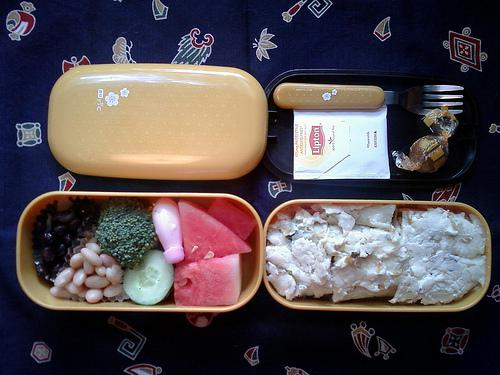Question: where is the food?
Choices:
A. On a counter.
B. On a chair.
C. On the stove.
D. On a table.
Answer with the letter. Answer: D Question: what is red?
Choices:
A. Banana.
B. Orange.
C. Watermelon.
D. Lemon.
Answer with the letter. Answer: C Question: why is there a fork?
Choices:
A. To drink with.
B. To look at.
C. To poke someone.
D. To eat with.
Answer with the letter. Answer: D Question: what is white?
Choices:
A. Fish.
B. Beef.
C. Bacon.
D. Dolphin.
Answer with the letter. Answer: A Question: when will this be eaten?
Choices:
A. Breakfast.
B. As a snack.
C. Lunch.
D. Dinner.
Answer with the letter. Answer: C Question: how many tea bags?
Choices:
A. Zero.
B. Three.
C. One.
D. Five.
Answer with the letter. Answer: C 